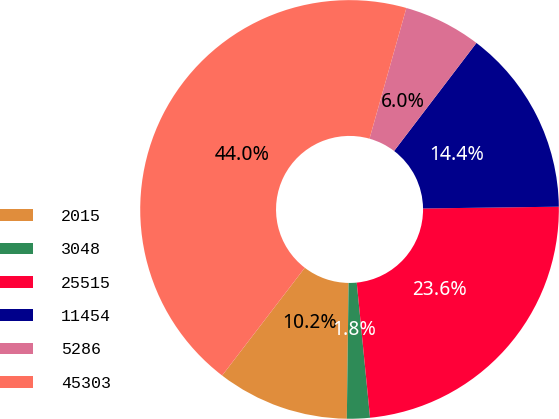Convert chart to OTSL. <chart><loc_0><loc_0><loc_500><loc_500><pie_chart><fcel>2015<fcel>3048<fcel>25515<fcel>11454<fcel>5286<fcel>45303<nl><fcel>10.21%<fcel>1.77%<fcel>23.65%<fcel>14.43%<fcel>5.99%<fcel>43.97%<nl></chart> 